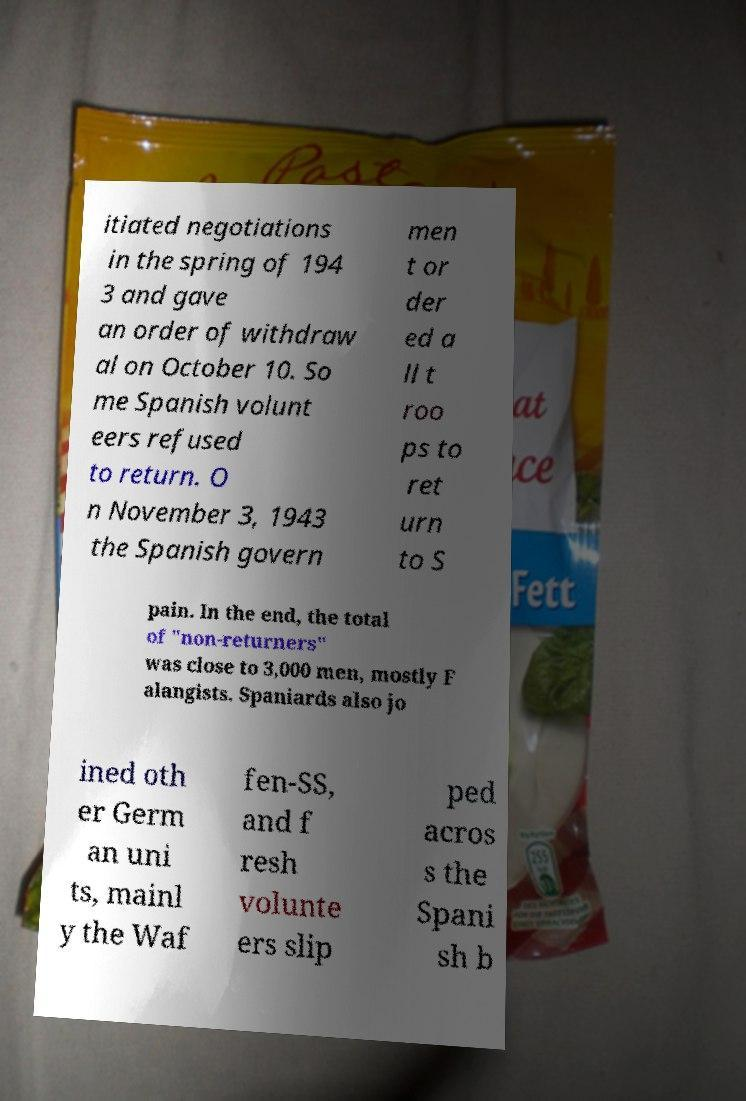Can you accurately transcribe the text from the provided image for me? itiated negotiations in the spring of 194 3 and gave an order of withdraw al on October 10. So me Spanish volunt eers refused to return. O n November 3, 1943 the Spanish govern men t or der ed a ll t roo ps to ret urn to S pain. In the end, the total of "non-returners" was close to 3,000 men, mostly F alangists. Spaniards also jo ined oth er Germ an uni ts, mainl y the Waf fen-SS, and f resh volunte ers slip ped acros s the Spani sh b 